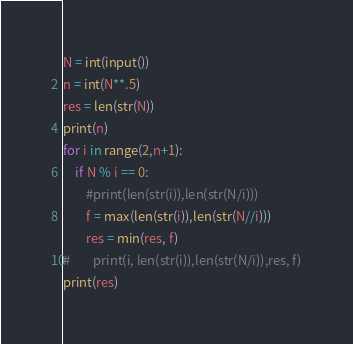Convert code to text. <code><loc_0><loc_0><loc_500><loc_500><_Python_>N = int(input()) 
n = int(N**.5)
res = len(str(N))
print(n)
for i in range(2,n+1):
    if N % i == 0:
        #print(len(str(i)),len(str(N/i)))
        f = max(len(str(i)),len(str(N//i)))
        res = min(res, f)
#        print(i, len(str(i)),len(str(N/i)),res, f)
print(res)
</code> 